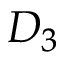Convert formula to latex. <formula><loc_0><loc_0><loc_500><loc_500>D _ { 3 }</formula> 